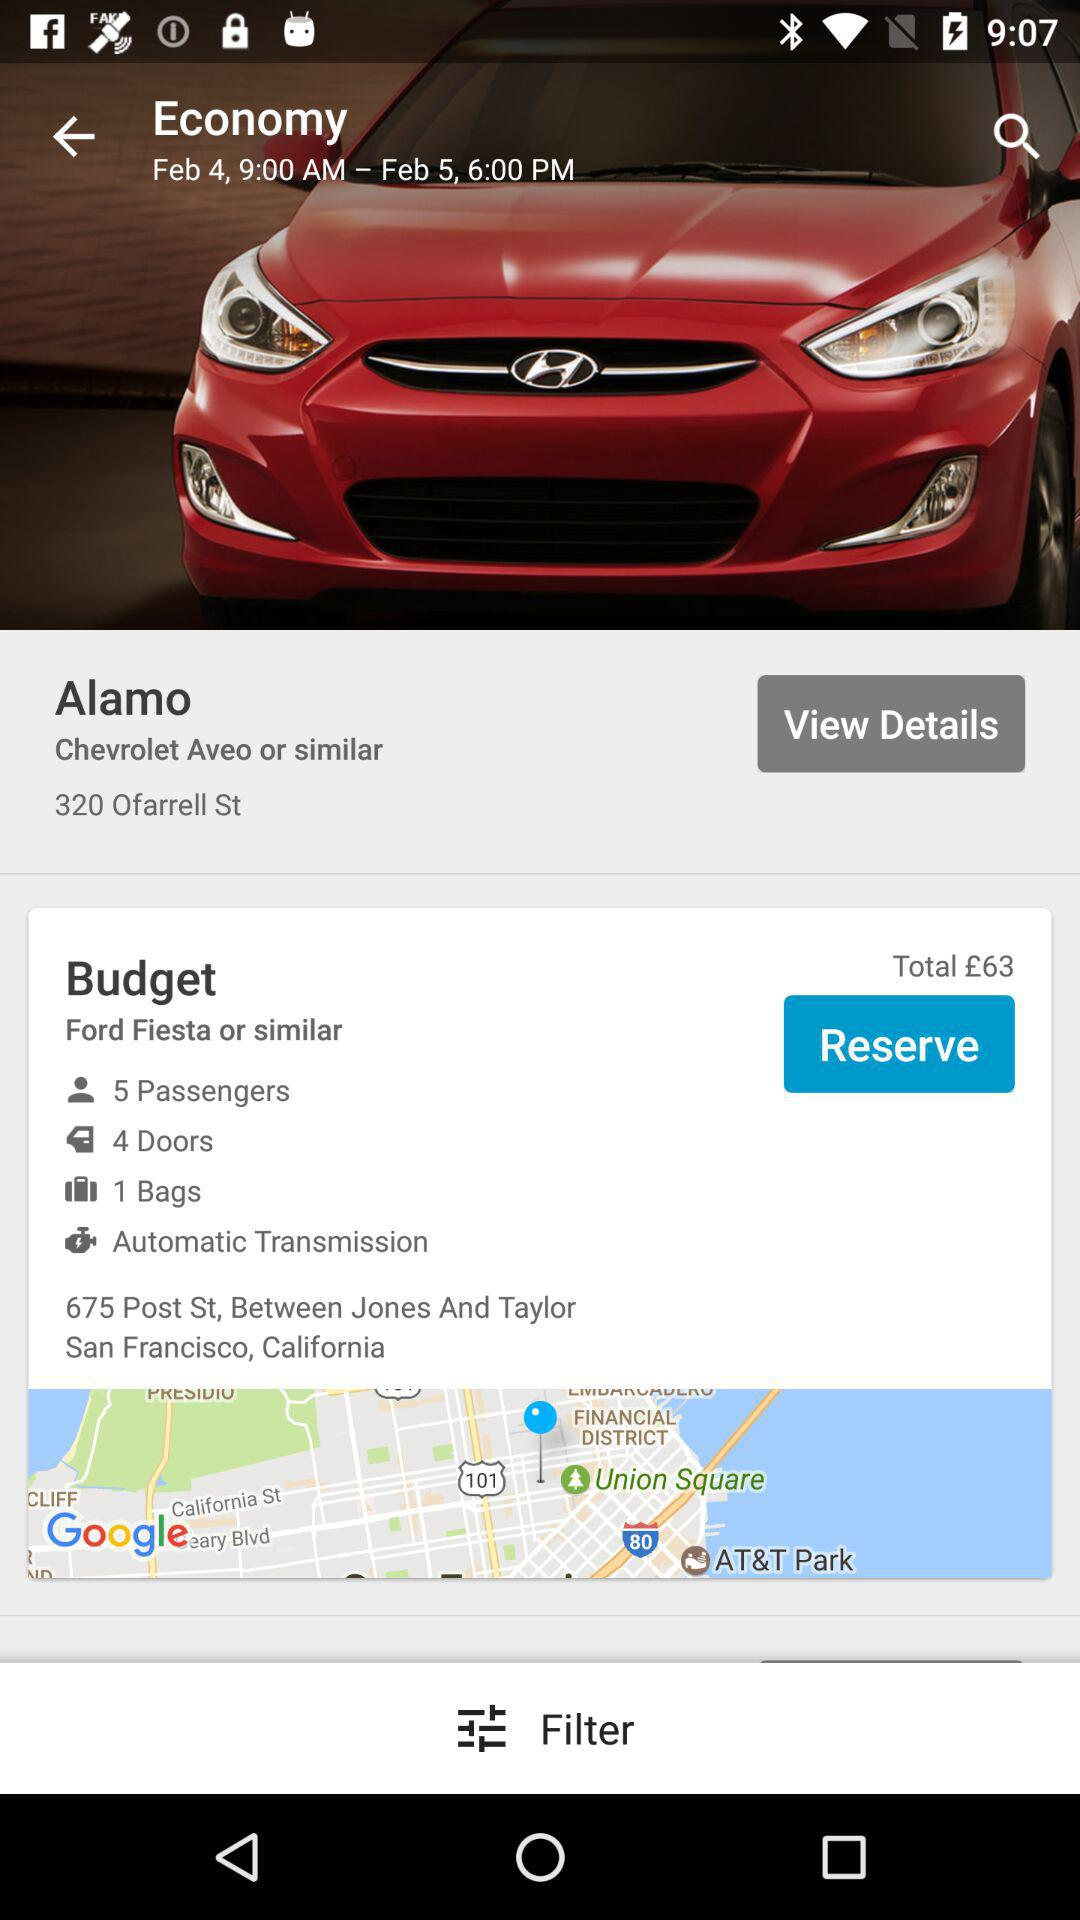What is the name of the car? The name of the car is "Chevrolet Aveo". 